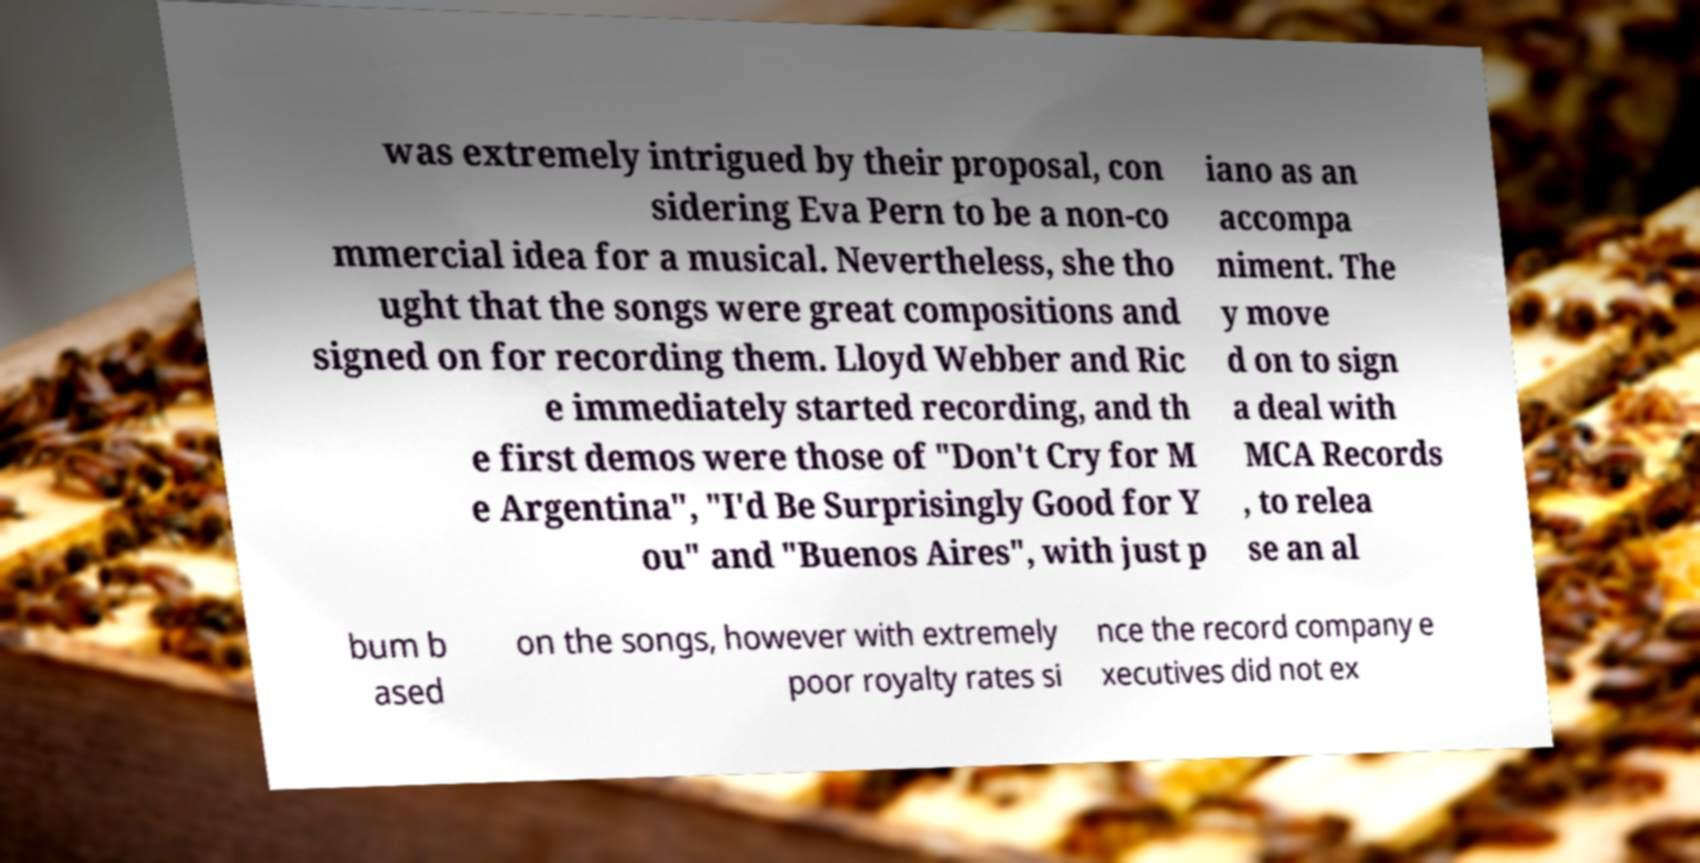Could you extract and type out the text from this image? was extremely intrigued by their proposal, con sidering Eva Pern to be a non-co mmercial idea for a musical. Nevertheless, she tho ught that the songs were great compositions and signed on for recording them. Lloyd Webber and Ric e immediately started recording, and th e first demos were those of "Don't Cry for M e Argentina", "I'd Be Surprisingly Good for Y ou" and "Buenos Aires", with just p iano as an accompa niment. The y move d on to sign a deal with MCA Records , to relea se an al bum b ased on the songs, however with extremely poor royalty rates si nce the record company e xecutives did not ex 